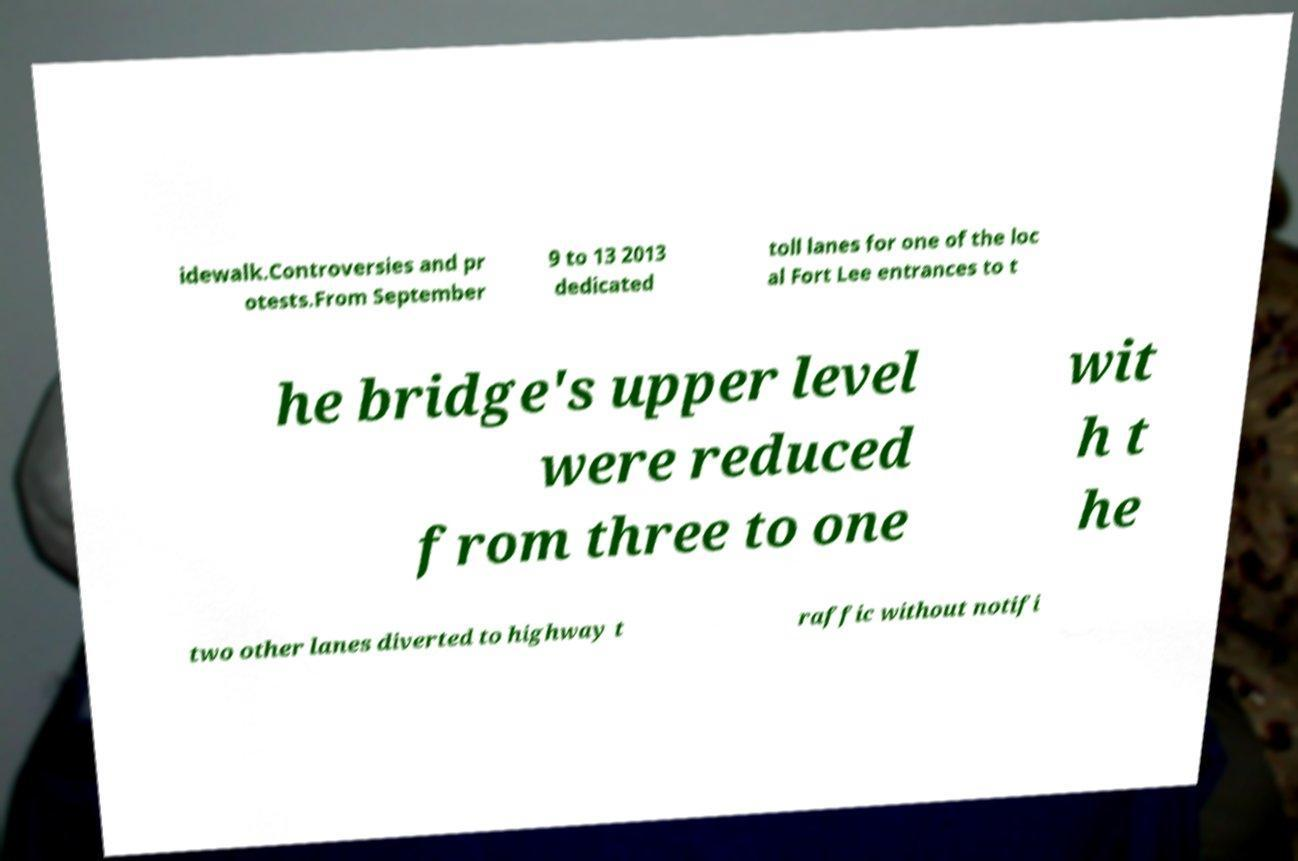Can you accurately transcribe the text from the provided image for me? idewalk.Controversies and pr otests.From September 9 to 13 2013 dedicated toll lanes for one of the loc al Fort Lee entrances to t he bridge's upper level were reduced from three to one wit h t he two other lanes diverted to highway t raffic without notifi 